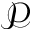<formula> <loc_0><loc_0><loc_500><loc_500>\mathcal { P }</formula> 